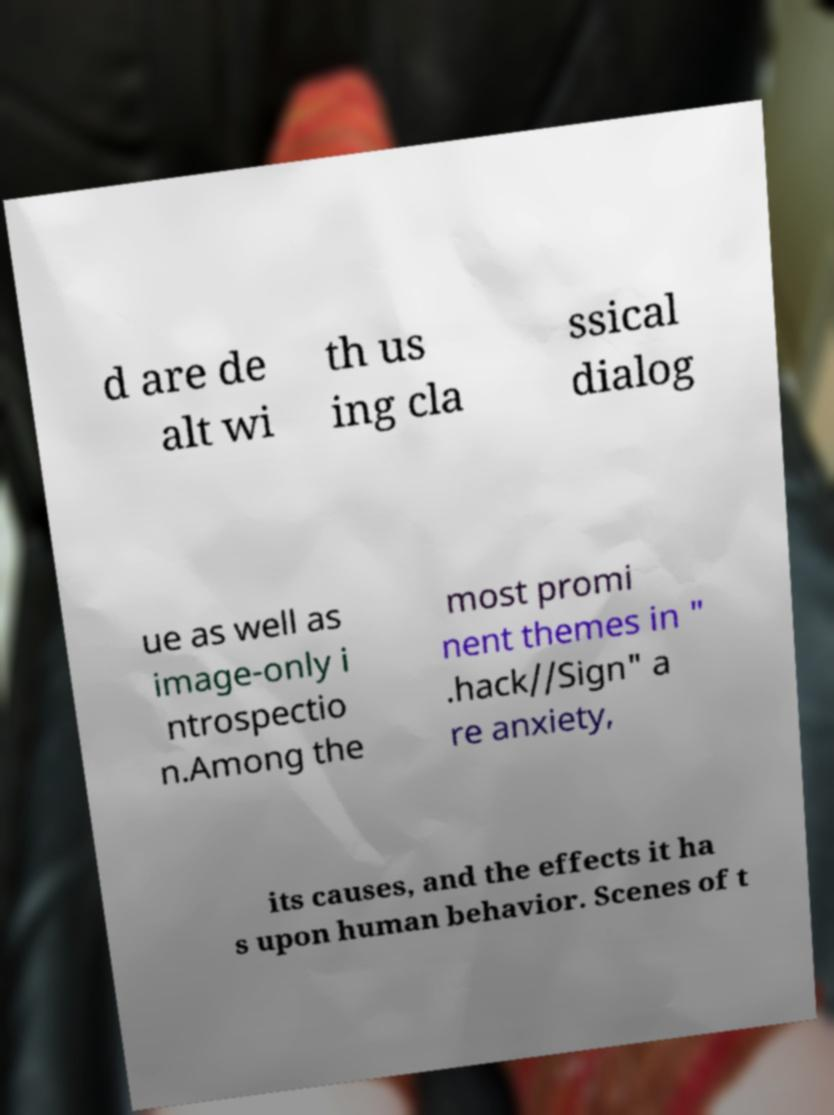Could you extract and type out the text from this image? d are de alt wi th us ing cla ssical dialog ue as well as image-only i ntrospectio n.Among the most promi nent themes in " .hack//Sign" a re anxiety, its causes, and the effects it ha s upon human behavior. Scenes of t 